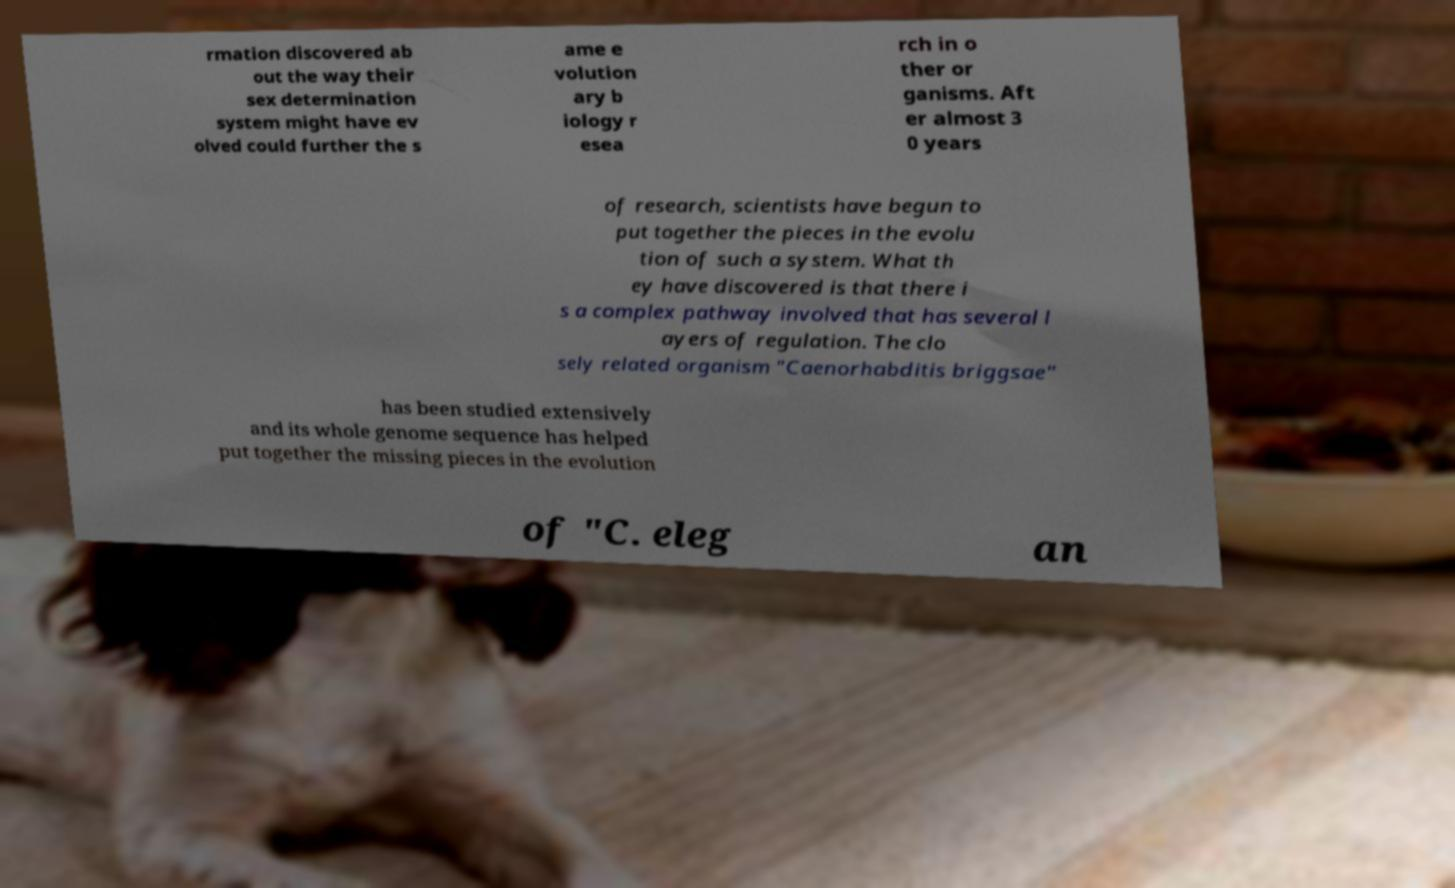Can you read and provide the text displayed in the image?This photo seems to have some interesting text. Can you extract and type it out for me? rmation discovered ab out the way their sex determination system might have ev olved could further the s ame e volution ary b iology r esea rch in o ther or ganisms. Aft er almost 3 0 years of research, scientists have begun to put together the pieces in the evolu tion of such a system. What th ey have discovered is that there i s a complex pathway involved that has several l ayers of regulation. The clo sely related organism "Caenorhabditis briggsae" has been studied extensively and its whole genome sequence has helped put together the missing pieces in the evolution of "C. eleg an 